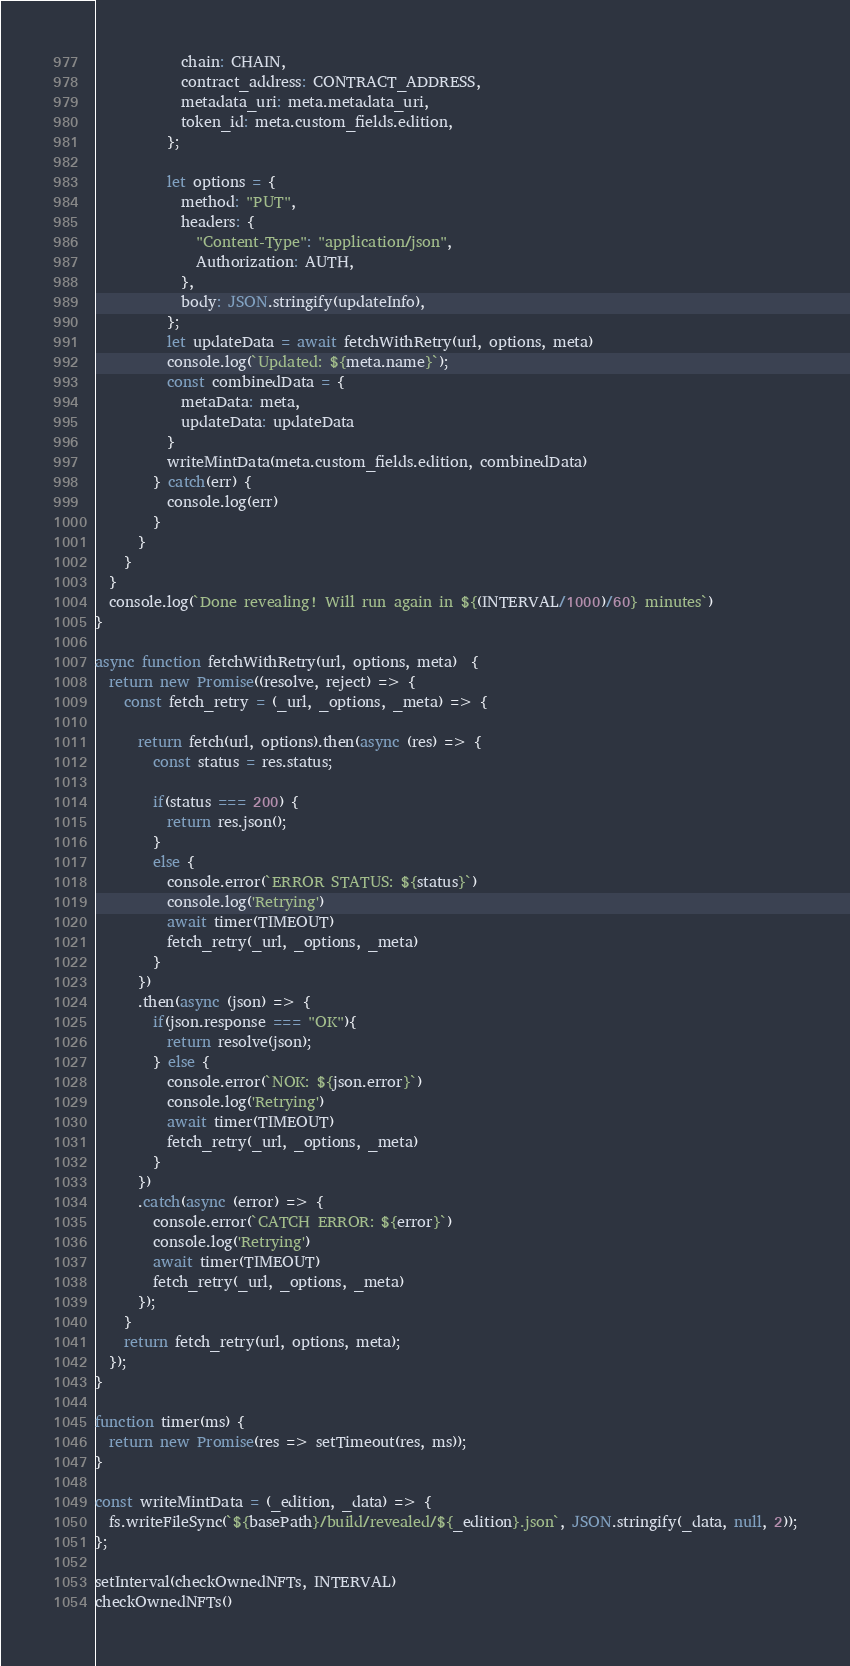Convert code to text. <code><loc_0><loc_0><loc_500><loc_500><_JavaScript_>            chain: CHAIN,
            contract_address: CONTRACT_ADDRESS,
            metadata_uri: meta.metadata_uri,
            token_id: meta.custom_fields.edition,
          };

          let options = {
            method: "PUT",
            headers: {
              "Content-Type": "application/json",
              Authorization: AUTH,
            },
            body: JSON.stringify(updateInfo),
          };
          let updateData = await fetchWithRetry(url, options, meta)
          console.log(`Updated: ${meta.name}`);
          const combinedData = {
            metaData: meta,
            updateData: updateData
          }
          writeMintData(meta.custom_fields.edition, combinedData)
        } catch(err) {
          console.log(err)
        }
      }
    }
  }
  console.log(`Done revealing! Will run again in ${(INTERVAL/1000)/60} minutes`)
}

async function fetchWithRetry(url, options, meta)  {
  return new Promise((resolve, reject) => {
    const fetch_retry = (_url, _options, _meta) => {
      
      return fetch(url, options).then(async (res) => {
        const status = res.status;

        if(status === 200) {
          return res.json();
        }            
        else {
          console.error(`ERROR STATUS: ${status}`)
          console.log('Retrying')
          await timer(TIMEOUT)
          fetch_retry(_url, _options, _meta)
        }            
      })
      .then(async (json) => {
        if(json.response === "OK"){
          return resolve(json);
        } else {
          console.error(`NOK: ${json.error}`)
          console.log('Retrying')
          await timer(TIMEOUT)
          fetch_retry(_url, _options, _meta)
        }
      })
      .catch(async (error) => {  
        console.error(`CATCH ERROR: ${error}`)  
        console.log('Retrying')    
        await timer(TIMEOUT)    
        fetch_retry(_url, _options, _meta)
      });
    }          
    return fetch_retry(url, options, meta);
  });
}

function timer(ms) {
  return new Promise(res => setTimeout(res, ms));
}

const writeMintData = (_edition, _data) => {
  fs.writeFileSync(`${basePath}/build/revealed/${_edition}.json`, JSON.stringify(_data, null, 2));
};

setInterval(checkOwnedNFTs, INTERVAL)
checkOwnedNFTs()</code> 